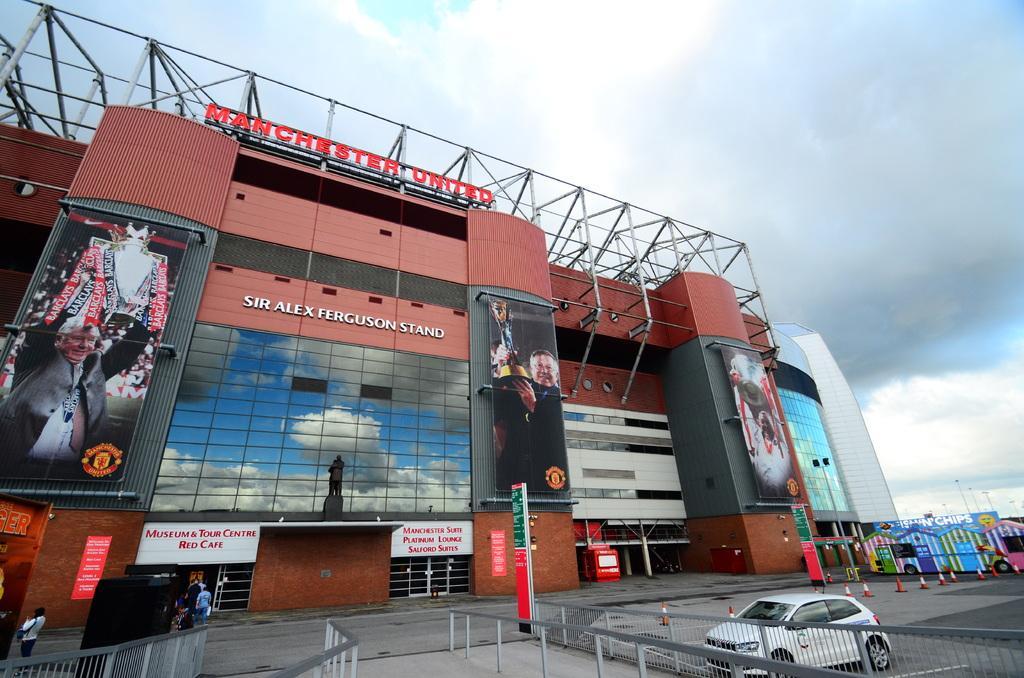Describe this image in one or two sentences. In the given picture, I can see a car parked and towards left, I can see a image lifting trophy and towards right corner, I can see a building and a electrical pole which includes lights and shopping complex, I can see few people going inside the building and towards left bottom two people standing. 